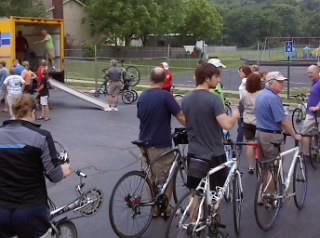Why might these people be lined up? Please explain your reasoning. donation. The moving truck in the background suggests the bikes will be transported elsewhere. 